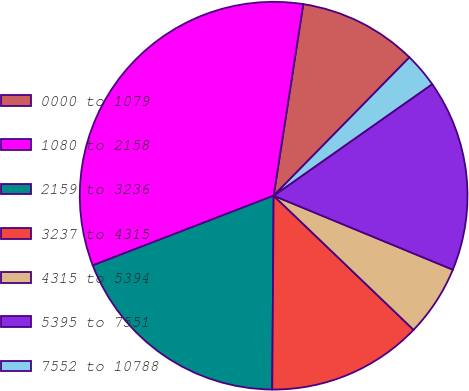<chart> <loc_0><loc_0><loc_500><loc_500><pie_chart><fcel>0000 to 1079<fcel>1080 to 2158<fcel>2159 to 3236<fcel>3237 to 4315<fcel>4315 to 5394<fcel>5395 to 7551<fcel>7552 to 10788<nl><fcel>9.91%<fcel>33.29%<fcel>19.03%<fcel>12.95%<fcel>5.93%<fcel>15.99%<fcel>2.89%<nl></chart> 